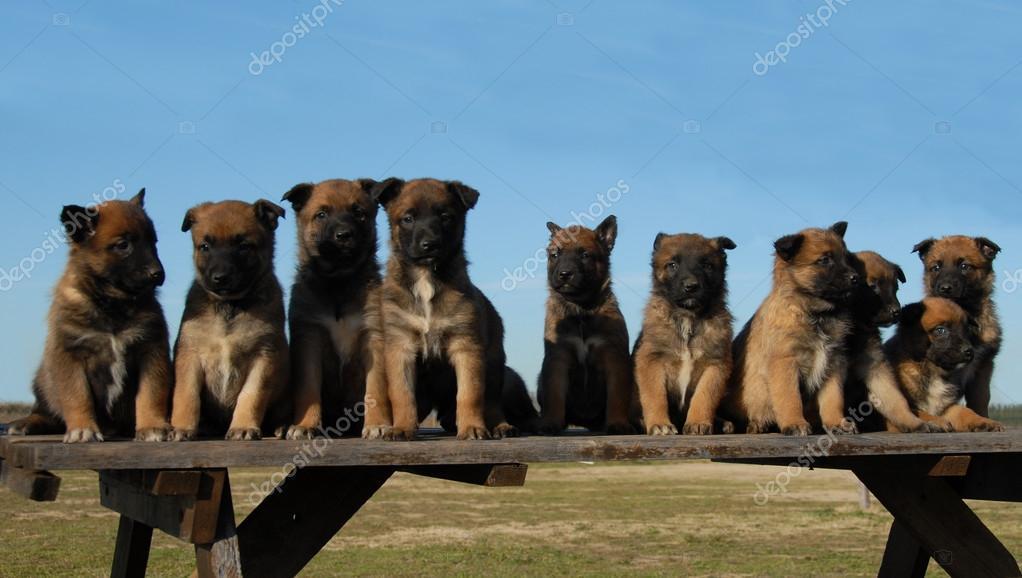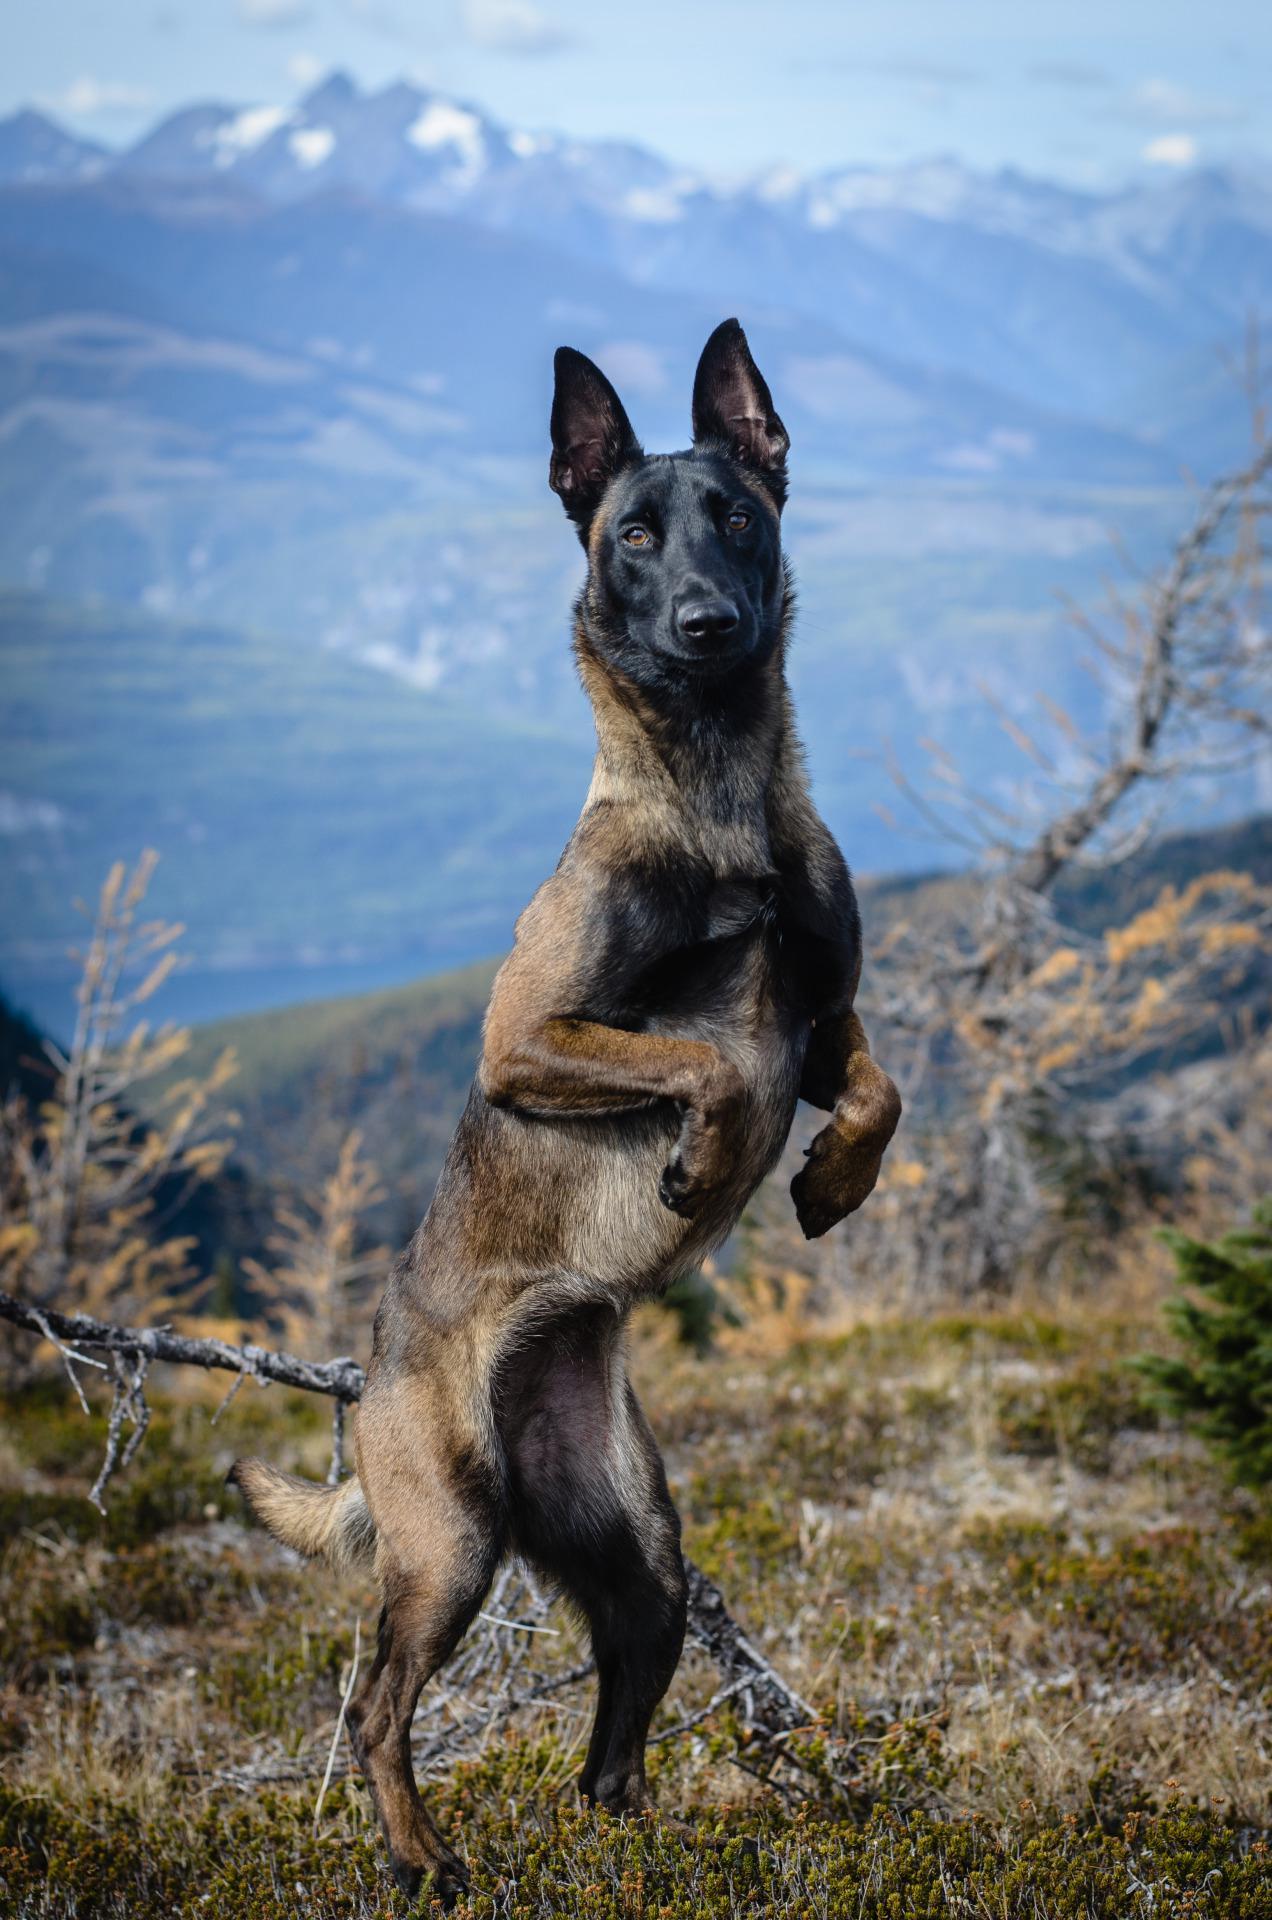The first image is the image on the left, the second image is the image on the right. Considering the images on both sides, is "An image shows dogs posed on a wooden bench." valid? Answer yes or no. Yes. 